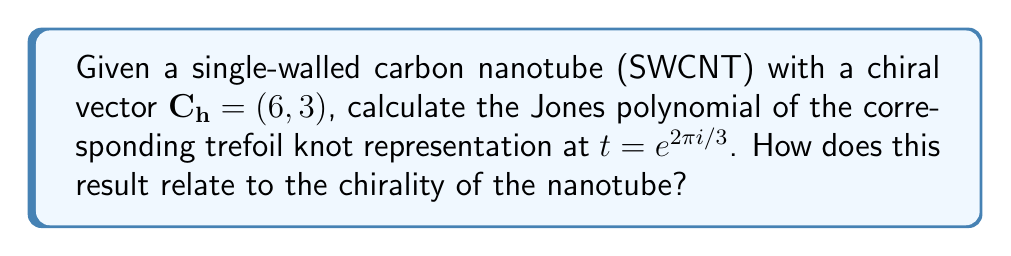Solve this math problem. To solve this problem, we'll follow these steps:

1) First, recall that the chiral vector $(n,m)$ of a SWCNT determines its structure and properties. In this case, $(6,3)$ indicates a chiral nanotube.

2) The trefoil knot is often used as a simplified representation of chiral nanotubes in knot theory. The Jones polynomial for a right-handed trefoil knot is:

   $$V(t) = t + t^3 - t^4$$

3) We need to evaluate this polynomial at $t = e^{2\pi i/3}$. Let's substitute:

   $$V(e^{2\pi i/3}) = e^{2\pi i/3} + (e^{2\pi i/3})^3 - (e^{2\pi i/3})^4$$

4) Simplify using Euler's formula $e^{ix} = \cos x + i\sin x$:

   $$e^{2\pi i/3} = -\frac{1}{2} + i\frac{\sqrt{3}}{2}$$

5) Calculate the powers:

   $$(e^{2\pi i/3})^3 = -1$$
   $$(e^{2\pi i/3})^4 = \frac{1}{2} - i\frac{\sqrt{3}}{2}$$

6) Substitute these values into the polynomial:

   $$V(e^{2\pi i/3}) = (-\frac{1}{2} + i\frac{\sqrt{3}}{2}) + (-1) - (\frac{1}{2} - i\frac{\sqrt{3}}{2})$$

7) Simplify:

   $$V(e^{2\pi i/3}) = -2 + i\sqrt{3}$$

8) The non-zero result indicates that the nanotube is chiral. If the nanotube were achiral, the Jones polynomial evaluated at this point would be real.
Answer: $-2 + i\sqrt{3}$; non-zero imaginary part confirms chirality 